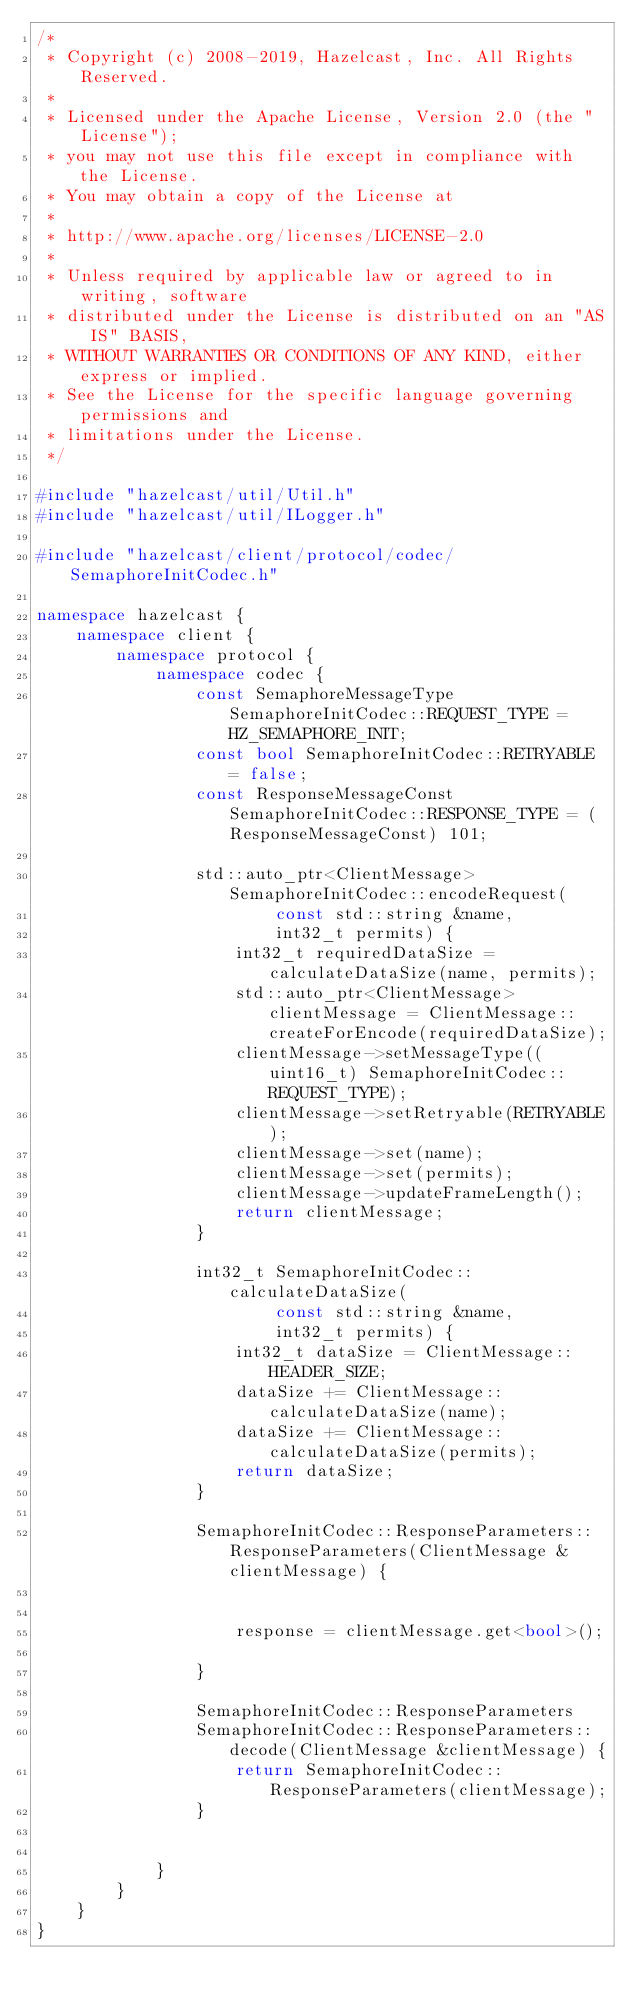Convert code to text. <code><loc_0><loc_0><loc_500><loc_500><_C++_>/*
 * Copyright (c) 2008-2019, Hazelcast, Inc. All Rights Reserved.
 *
 * Licensed under the Apache License, Version 2.0 (the "License");
 * you may not use this file except in compliance with the License.
 * You may obtain a copy of the License at
 *
 * http://www.apache.org/licenses/LICENSE-2.0
 *
 * Unless required by applicable law or agreed to in writing, software
 * distributed under the License is distributed on an "AS IS" BASIS,
 * WITHOUT WARRANTIES OR CONDITIONS OF ANY KIND, either express or implied.
 * See the License for the specific language governing permissions and
 * limitations under the License.
 */

#include "hazelcast/util/Util.h"
#include "hazelcast/util/ILogger.h"

#include "hazelcast/client/protocol/codec/SemaphoreInitCodec.h"

namespace hazelcast {
    namespace client {
        namespace protocol {
            namespace codec {
                const SemaphoreMessageType SemaphoreInitCodec::REQUEST_TYPE = HZ_SEMAPHORE_INIT;
                const bool SemaphoreInitCodec::RETRYABLE = false;
                const ResponseMessageConst SemaphoreInitCodec::RESPONSE_TYPE = (ResponseMessageConst) 101;

                std::auto_ptr<ClientMessage> SemaphoreInitCodec::encodeRequest(
                        const std::string &name,
                        int32_t permits) {
                    int32_t requiredDataSize = calculateDataSize(name, permits);
                    std::auto_ptr<ClientMessage> clientMessage = ClientMessage::createForEncode(requiredDataSize);
                    clientMessage->setMessageType((uint16_t) SemaphoreInitCodec::REQUEST_TYPE);
                    clientMessage->setRetryable(RETRYABLE);
                    clientMessage->set(name);
                    clientMessage->set(permits);
                    clientMessage->updateFrameLength();
                    return clientMessage;
                }

                int32_t SemaphoreInitCodec::calculateDataSize(
                        const std::string &name,
                        int32_t permits) {
                    int32_t dataSize = ClientMessage::HEADER_SIZE;
                    dataSize += ClientMessage::calculateDataSize(name);
                    dataSize += ClientMessage::calculateDataSize(permits);
                    return dataSize;
                }

                SemaphoreInitCodec::ResponseParameters::ResponseParameters(ClientMessage &clientMessage) {


                    response = clientMessage.get<bool>();

                }

                SemaphoreInitCodec::ResponseParameters
                SemaphoreInitCodec::ResponseParameters::decode(ClientMessage &clientMessage) {
                    return SemaphoreInitCodec::ResponseParameters(clientMessage);
                }


            }
        }
    }
}

</code> 